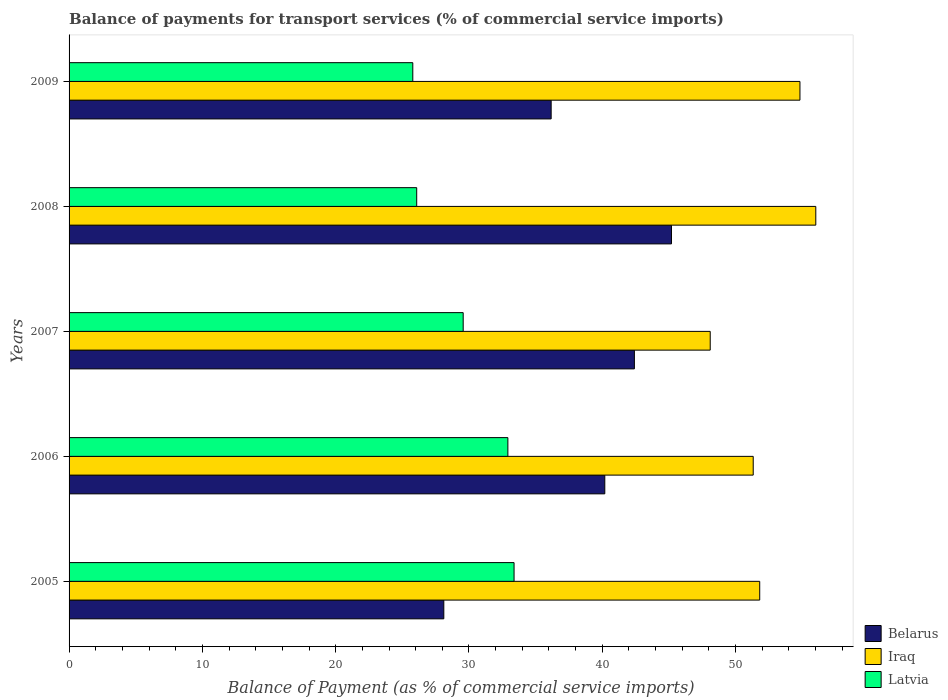In how many cases, is the number of bars for a given year not equal to the number of legend labels?
Offer a terse response. 0. What is the balance of payments for transport services in Iraq in 2006?
Ensure brevity in your answer.  51.32. Across all years, what is the maximum balance of payments for transport services in Iraq?
Your answer should be compact. 56.02. Across all years, what is the minimum balance of payments for transport services in Latvia?
Ensure brevity in your answer.  25.79. What is the total balance of payments for transport services in Iraq in the graph?
Your answer should be compact. 262.07. What is the difference between the balance of payments for transport services in Iraq in 2008 and that in 2009?
Offer a terse response. 1.19. What is the difference between the balance of payments for transport services in Latvia in 2008 and the balance of payments for transport services in Iraq in 2007?
Keep it short and to the point. -22.02. What is the average balance of payments for transport services in Belarus per year?
Offer a very short reply. 38.41. In the year 2007, what is the difference between the balance of payments for transport services in Latvia and balance of payments for transport services in Iraq?
Your response must be concise. -18.53. What is the ratio of the balance of payments for transport services in Iraq in 2006 to that in 2007?
Your response must be concise. 1.07. Is the balance of payments for transport services in Latvia in 2006 less than that in 2009?
Ensure brevity in your answer.  No. What is the difference between the highest and the second highest balance of payments for transport services in Belarus?
Provide a short and direct response. 2.78. What is the difference between the highest and the lowest balance of payments for transport services in Latvia?
Ensure brevity in your answer.  7.6. In how many years, is the balance of payments for transport services in Belarus greater than the average balance of payments for transport services in Belarus taken over all years?
Give a very brief answer. 3. What does the 1st bar from the top in 2006 represents?
Your response must be concise. Latvia. What does the 3rd bar from the bottom in 2008 represents?
Give a very brief answer. Latvia. Is it the case that in every year, the sum of the balance of payments for transport services in Latvia and balance of payments for transport services in Iraq is greater than the balance of payments for transport services in Belarus?
Offer a terse response. Yes. Are all the bars in the graph horizontal?
Your response must be concise. Yes. What is the difference between two consecutive major ticks on the X-axis?
Give a very brief answer. 10. Does the graph contain grids?
Your answer should be very brief. No. Where does the legend appear in the graph?
Make the answer very short. Bottom right. What is the title of the graph?
Provide a short and direct response. Balance of payments for transport services (% of commercial service imports). Does "Tanzania" appear as one of the legend labels in the graph?
Give a very brief answer. No. What is the label or title of the X-axis?
Offer a terse response. Balance of Payment (as % of commercial service imports). What is the label or title of the Y-axis?
Keep it short and to the point. Years. What is the Balance of Payment (as % of commercial service imports) of Belarus in 2005?
Your response must be concise. 28.11. What is the Balance of Payment (as % of commercial service imports) in Iraq in 2005?
Give a very brief answer. 51.81. What is the Balance of Payment (as % of commercial service imports) in Latvia in 2005?
Offer a terse response. 33.38. What is the Balance of Payment (as % of commercial service imports) of Belarus in 2006?
Give a very brief answer. 40.19. What is the Balance of Payment (as % of commercial service imports) in Iraq in 2006?
Offer a terse response. 51.32. What is the Balance of Payment (as % of commercial service imports) in Latvia in 2006?
Offer a terse response. 32.92. What is the Balance of Payment (as % of commercial service imports) in Belarus in 2007?
Provide a succinct answer. 42.41. What is the Balance of Payment (as % of commercial service imports) of Iraq in 2007?
Your answer should be compact. 48.1. What is the Balance of Payment (as % of commercial service imports) in Latvia in 2007?
Give a very brief answer. 29.56. What is the Balance of Payment (as % of commercial service imports) in Belarus in 2008?
Keep it short and to the point. 45.19. What is the Balance of Payment (as % of commercial service imports) in Iraq in 2008?
Offer a terse response. 56.02. What is the Balance of Payment (as % of commercial service imports) of Latvia in 2008?
Make the answer very short. 26.08. What is the Balance of Payment (as % of commercial service imports) in Belarus in 2009?
Your answer should be very brief. 36.16. What is the Balance of Payment (as % of commercial service imports) of Iraq in 2009?
Offer a terse response. 54.83. What is the Balance of Payment (as % of commercial service imports) of Latvia in 2009?
Offer a terse response. 25.79. Across all years, what is the maximum Balance of Payment (as % of commercial service imports) of Belarus?
Your answer should be very brief. 45.19. Across all years, what is the maximum Balance of Payment (as % of commercial service imports) in Iraq?
Your answer should be compact. 56.02. Across all years, what is the maximum Balance of Payment (as % of commercial service imports) in Latvia?
Ensure brevity in your answer.  33.38. Across all years, what is the minimum Balance of Payment (as % of commercial service imports) in Belarus?
Make the answer very short. 28.11. Across all years, what is the minimum Balance of Payment (as % of commercial service imports) in Iraq?
Give a very brief answer. 48.1. Across all years, what is the minimum Balance of Payment (as % of commercial service imports) of Latvia?
Offer a very short reply. 25.79. What is the total Balance of Payment (as % of commercial service imports) of Belarus in the graph?
Give a very brief answer. 192.06. What is the total Balance of Payment (as % of commercial service imports) in Iraq in the graph?
Your answer should be very brief. 262.07. What is the total Balance of Payment (as % of commercial service imports) in Latvia in the graph?
Your response must be concise. 147.73. What is the difference between the Balance of Payment (as % of commercial service imports) of Belarus in 2005 and that in 2006?
Provide a succinct answer. -12.08. What is the difference between the Balance of Payment (as % of commercial service imports) of Iraq in 2005 and that in 2006?
Offer a very short reply. 0.49. What is the difference between the Balance of Payment (as % of commercial service imports) of Latvia in 2005 and that in 2006?
Offer a very short reply. 0.46. What is the difference between the Balance of Payment (as % of commercial service imports) in Belarus in 2005 and that in 2007?
Offer a very short reply. -14.3. What is the difference between the Balance of Payment (as % of commercial service imports) of Iraq in 2005 and that in 2007?
Offer a very short reply. 3.71. What is the difference between the Balance of Payment (as % of commercial service imports) in Latvia in 2005 and that in 2007?
Offer a very short reply. 3.82. What is the difference between the Balance of Payment (as % of commercial service imports) in Belarus in 2005 and that in 2008?
Provide a succinct answer. -17.08. What is the difference between the Balance of Payment (as % of commercial service imports) of Iraq in 2005 and that in 2008?
Provide a short and direct response. -4.21. What is the difference between the Balance of Payment (as % of commercial service imports) of Latvia in 2005 and that in 2008?
Provide a short and direct response. 7.3. What is the difference between the Balance of Payment (as % of commercial service imports) of Belarus in 2005 and that in 2009?
Provide a short and direct response. -8.05. What is the difference between the Balance of Payment (as % of commercial service imports) of Iraq in 2005 and that in 2009?
Your answer should be very brief. -3.02. What is the difference between the Balance of Payment (as % of commercial service imports) of Latvia in 2005 and that in 2009?
Make the answer very short. 7.6. What is the difference between the Balance of Payment (as % of commercial service imports) of Belarus in 2006 and that in 2007?
Provide a short and direct response. -2.22. What is the difference between the Balance of Payment (as % of commercial service imports) in Iraq in 2006 and that in 2007?
Offer a very short reply. 3.22. What is the difference between the Balance of Payment (as % of commercial service imports) of Latvia in 2006 and that in 2007?
Your answer should be compact. 3.35. What is the difference between the Balance of Payment (as % of commercial service imports) in Belarus in 2006 and that in 2008?
Provide a short and direct response. -5. What is the difference between the Balance of Payment (as % of commercial service imports) in Iraq in 2006 and that in 2008?
Ensure brevity in your answer.  -4.69. What is the difference between the Balance of Payment (as % of commercial service imports) of Latvia in 2006 and that in 2008?
Your answer should be compact. 6.84. What is the difference between the Balance of Payment (as % of commercial service imports) of Belarus in 2006 and that in 2009?
Ensure brevity in your answer.  4.02. What is the difference between the Balance of Payment (as % of commercial service imports) in Iraq in 2006 and that in 2009?
Your answer should be very brief. -3.51. What is the difference between the Balance of Payment (as % of commercial service imports) of Latvia in 2006 and that in 2009?
Provide a short and direct response. 7.13. What is the difference between the Balance of Payment (as % of commercial service imports) in Belarus in 2007 and that in 2008?
Your answer should be very brief. -2.78. What is the difference between the Balance of Payment (as % of commercial service imports) of Iraq in 2007 and that in 2008?
Your answer should be very brief. -7.92. What is the difference between the Balance of Payment (as % of commercial service imports) in Latvia in 2007 and that in 2008?
Your answer should be compact. 3.49. What is the difference between the Balance of Payment (as % of commercial service imports) in Belarus in 2007 and that in 2009?
Offer a very short reply. 6.24. What is the difference between the Balance of Payment (as % of commercial service imports) in Iraq in 2007 and that in 2009?
Offer a terse response. -6.73. What is the difference between the Balance of Payment (as % of commercial service imports) of Latvia in 2007 and that in 2009?
Your answer should be compact. 3.78. What is the difference between the Balance of Payment (as % of commercial service imports) in Belarus in 2008 and that in 2009?
Keep it short and to the point. 9.03. What is the difference between the Balance of Payment (as % of commercial service imports) in Iraq in 2008 and that in 2009?
Provide a succinct answer. 1.19. What is the difference between the Balance of Payment (as % of commercial service imports) of Latvia in 2008 and that in 2009?
Make the answer very short. 0.29. What is the difference between the Balance of Payment (as % of commercial service imports) in Belarus in 2005 and the Balance of Payment (as % of commercial service imports) in Iraq in 2006?
Provide a succinct answer. -23.21. What is the difference between the Balance of Payment (as % of commercial service imports) in Belarus in 2005 and the Balance of Payment (as % of commercial service imports) in Latvia in 2006?
Offer a terse response. -4.81. What is the difference between the Balance of Payment (as % of commercial service imports) in Iraq in 2005 and the Balance of Payment (as % of commercial service imports) in Latvia in 2006?
Your answer should be very brief. 18.89. What is the difference between the Balance of Payment (as % of commercial service imports) of Belarus in 2005 and the Balance of Payment (as % of commercial service imports) of Iraq in 2007?
Your answer should be very brief. -19.99. What is the difference between the Balance of Payment (as % of commercial service imports) in Belarus in 2005 and the Balance of Payment (as % of commercial service imports) in Latvia in 2007?
Ensure brevity in your answer.  -1.45. What is the difference between the Balance of Payment (as % of commercial service imports) of Iraq in 2005 and the Balance of Payment (as % of commercial service imports) of Latvia in 2007?
Provide a succinct answer. 22.24. What is the difference between the Balance of Payment (as % of commercial service imports) of Belarus in 2005 and the Balance of Payment (as % of commercial service imports) of Iraq in 2008?
Your response must be concise. -27.9. What is the difference between the Balance of Payment (as % of commercial service imports) in Belarus in 2005 and the Balance of Payment (as % of commercial service imports) in Latvia in 2008?
Offer a very short reply. 2.03. What is the difference between the Balance of Payment (as % of commercial service imports) in Iraq in 2005 and the Balance of Payment (as % of commercial service imports) in Latvia in 2008?
Give a very brief answer. 25.73. What is the difference between the Balance of Payment (as % of commercial service imports) in Belarus in 2005 and the Balance of Payment (as % of commercial service imports) in Iraq in 2009?
Your answer should be compact. -26.72. What is the difference between the Balance of Payment (as % of commercial service imports) in Belarus in 2005 and the Balance of Payment (as % of commercial service imports) in Latvia in 2009?
Give a very brief answer. 2.33. What is the difference between the Balance of Payment (as % of commercial service imports) of Iraq in 2005 and the Balance of Payment (as % of commercial service imports) of Latvia in 2009?
Keep it short and to the point. 26.02. What is the difference between the Balance of Payment (as % of commercial service imports) of Belarus in 2006 and the Balance of Payment (as % of commercial service imports) of Iraq in 2007?
Ensure brevity in your answer.  -7.91. What is the difference between the Balance of Payment (as % of commercial service imports) of Belarus in 2006 and the Balance of Payment (as % of commercial service imports) of Latvia in 2007?
Offer a terse response. 10.62. What is the difference between the Balance of Payment (as % of commercial service imports) in Iraq in 2006 and the Balance of Payment (as % of commercial service imports) in Latvia in 2007?
Ensure brevity in your answer.  21.76. What is the difference between the Balance of Payment (as % of commercial service imports) in Belarus in 2006 and the Balance of Payment (as % of commercial service imports) in Iraq in 2008?
Offer a terse response. -15.83. What is the difference between the Balance of Payment (as % of commercial service imports) in Belarus in 2006 and the Balance of Payment (as % of commercial service imports) in Latvia in 2008?
Give a very brief answer. 14.11. What is the difference between the Balance of Payment (as % of commercial service imports) of Iraq in 2006 and the Balance of Payment (as % of commercial service imports) of Latvia in 2008?
Your answer should be very brief. 25.24. What is the difference between the Balance of Payment (as % of commercial service imports) of Belarus in 2006 and the Balance of Payment (as % of commercial service imports) of Iraq in 2009?
Provide a succinct answer. -14.64. What is the difference between the Balance of Payment (as % of commercial service imports) of Belarus in 2006 and the Balance of Payment (as % of commercial service imports) of Latvia in 2009?
Offer a terse response. 14.4. What is the difference between the Balance of Payment (as % of commercial service imports) in Iraq in 2006 and the Balance of Payment (as % of commercial service imports) in Latvia in 2009?
Ensure brevity in your answer.  25.54. What is the difference between the Balance of Payment (as % of commercial service imports) in Belarus in 2007 and the Balance of Payment (as % of commercial service imports) in Iraq in 2008?
Provide a succinct answer. -13.61. What is the difference between the Balance of Payment (as % of commercial service imports) of Belarus in 2007 and the Balance of Payment (as % of commercial service imports) of Latvia in 2008?
Offer a terse response. 16.33. What is the difference between the Balance of Payment (as % of commercial service imports) in Iraq in 2007 and the Balance of Payment (as % of commercial service imports) in Latvia in 2008?
Make the answer very short. 22.02. What is the difference between the Balance of Payment (as % of commercial service imports) of Belarus in 2007 and the Balance of Payment (as % of commercial service imports) of Iraq in 2009?
Your response must be concise. -12.42. What is the difference between the Balance of Payment (as % of commercial service imports) of Belarus in 2007 and the Balance of Payment (as % of commercial service imports) of Latvia in 2009?
Keep it short and to the point. 16.62. What is the difference between the Balance of Payment (as % of commercial service imports) in Iraq in 2007 and the Balance of Payment (as % of commercial service imports) in Latvia in 2009?
Offer a terse response. 22.31. What is the difference between the Balance of Payment (as % of commercial service imports) of Belarus in 2008 and the Balance of Payment (as % of commercial service imports) of Iraq in 2009?
Offer a very short reply. -9.64. What is the difference between the Balance of Payment (as % of commercial service imports) in Belarus in 2008 and the Balance of Payment (as % of commercial service imports) in Latvia in 2009?
Your response must be concise. 19.41. What is the difference between the Balance of Payment (as % of commercial service imports) in Iraq in 2008 and the Balance of Payment (as % of commercial service imports) in Latvia in 2009?
Your answer should be very brief. 30.23. What is the average Balance of Payment (as % of commercial service imports) of Belarus per year?
Your answer should be very brief. 38.41. What is the average Balance of Payment (as % of commercial service imports) of Iraq per year?
Give a very brief answer. 52.41. What is the average Balance of Payment (as % of commercial service imports) in Latvia per year?
Your response must be concise. 29.55. In the year 2005, what is the difference between the Balance of Payment (as % of commercial service imports) of Belarus and Balance of Payment (as % of commercial service imports) of Iraq?
Provide a short and direct response. -23.7. In the year 2005, what is the difference between the Balance of Payment (as % of commercial service imports) in Belarus and Balance of Payment (as % of commercial service imports) in Latvia?
Ensure brevity in your answer.  -5.27. In the year 2005, what is the difference between the Balance of Payment (as % of commercial service imports) of Iraq and Balance of Payment (as % of commercial service imports) of Latvia?
Offer a terse response. 18.43. In the year 2006, what is the difference between the Balance of Payment (as % of commercial service imports) in Belarus and Balance of Payment (as % of commercial service imports) in Iraq?
Ensure brevity in your answer.  -11.13. In the year 2006, what is the difference between the Balance of Payment (as % of commercial service imports) in Belarus and Balance of Payment (as % of commercial service imports) in Latvia?
Provide a succinct answer. 7.27. In the year 2006, what is the difference between the Balance of Payment (as % of commercial service imports) in Iraq and Balance of Payment (as % of commercial service imports) in Latvia?
Keep it short and to the point. 18.4. In the year 2007, what is the difference between the Balance of Payment (as % of commercial service imports) of Belarus and Balance of Payment (as % of commercial service imports) of Iraq?
Provide a short and direct response. -5.69. In the year 2007, what is the difference between the Balance of Payment (as % of commercial service imports) in Belarus and Balance of Payment (as % of commercial service imports) in Latvia?
Your answer should be compact. 12.84. In the year 2007, what is the difference between the Balance of Payment (as % of commercial service imports) in Iraq and Balance of Payment (as % of commercial service imports) in Latvia?
Offer a very short reply. 18.53. In the year 2008, what is the difference between the Balance of Payment (as % of commercial service imports) of Belarus and Balance of Payment (as % of commercial service imports) of Iraq?
Offer a very short reply. -10.83. In the year 2008, what is the difference between the Balance of Payment (as % of commercial service imports) of Belarus and Balance of Payment (as % of commercial service imports) of Latvia?
Your answer should be compact. 19.11. In the year 2008, what is the difference between the Balance of Payment (as % of commercial service imports) in Iraq and Balance of Payment (as % of commercial service imports) in Latvia?
Your answer should be compact. 29.94. In the year 2009, what is the difference between the Balance of Payment (as % of commercial service imports) in Belarus and Balance of Payment (as % of commercial service imports) in Iraq?
Your answer should be compact. -18.66. In the year 2009, what is the difference between the Balance of Payment (as % of commercial service imports) of Belarus and Balance of Payment (as % of commercial service imports) of Latvia?
Ensure brevity in your answer.  10.38. In the year 2009, what is the difference between the Balance of Payment (as % of commercial service imports) in Iraq and Balance of Payment (as % of commercial service imports) in Latvia?
Offer a terse response. 29.04. What is the ratio of the Balance of Payment (as % of commercial service imports) in Belarus in 2005 to that in 2006?
Your answer should be very brief. 0.7. What is the ratio of the Balance of Payment (as % of commercial service imports) of Iraq in 2005 to that in 2006?
Your response must be concise. 1.01. What is the ratio of the Balance of Payment (as % of commercial service imports) in Latvia in 2005 to that in 2006?
Provide a short and direct response. 1.01. What is the ratio of the Balance of Payment (as % of commercial service imports) in Belarus in 2005 to that in 2007?
Your answer should be compact. 0.66. What is the ratio of the Balance of Payment (as % of commercial service imports) of Iraq in 2005 to that in 2007?
Give a very brief answer. 1.08. What is the ratio of the Balance of Payment (as % of commercial service imports) in Latvia in 2005 to that in 2007?
Offer a very short reply. 1.13. What is the ratio of the Balance of Payment (as % of commercial service imports) of Belarus in 2005 to that in 2008?
Offer a terse response. 0.62. What is the ratio of the Balance of Payment (as % of commercial service imports) of Iraq in 2005 to that in 2008?
Provide a short and direct response. 0.92. What is the ratio of the Balance of Payment (as % of commercial service imports) of Latvia in 2005 to that in 2008?
Your answer should be very brief. 1.28. What is the ratio of the Balance of Payment (as % of commercial service imports) of Belarus in 2005 to that in 2009?
Make the answer very short. 0.78. What is the ratio of the Balance of Payment (as % of commercial service imports) of Iraq in 2005 to that in 2009?
Give a very brief answer. 0.94. What is the ratio of the Balance of Payment (as % of commercial service imports) in Latvia in 2005 to that in 2009?
Ensure brevity in your answer.  1.29. What is the ratio of the Balance of Payment (as % of commercial service imports) in Belarus in 2006 to that in 2007?
Provide a succinct answer. 0.95. What is the ratio of the Balance of Payment (as % of commercial service imports) of Iraq in 2006 to that in 2007?
Make the answer very short. 1.07. What is the ratio of the Balance of Payment (as % of commercial service imports) in Latvia in 2006 to that in 2007?
Provide a short and direct response. 1.11. What is the ratio of the Balance of Payment (as % of commercial service imports) of Belarus in 2006 to that in 2008?
Make the answer very short. 0.89. What is the ratio of the Balance of Payment (as % of commercial service imports) of Iraq in 2006 to that in 2008?
Provide a succinct answer. 0.92. What is the ratio of the Balance of Payment (as % of commercial service imports) in Latvia in 2006 to that in 2008?
Keep it short and to the point. 1.26. What is the ratio of the Balance of Payment (as % of commercial service imports) in Belarus in 2006 to that in 2009?
Provide a succinct answer. 1.11. What is the ratio of the Balance of Payment (as % of commercial service imports) in Iraq in 2006 to that in 2009?
Keep it short and to the point. 0.94. What is the ratio of the Balance of Payment (as % of commercial service imports) in Latvia in 2006 to that in 2009?
Offer a very short reply. 1.28. What is the ratio of the Balance of Payment (as % of commercial service imports) of Belarus in 2007 to that in 2008?
Offer a very short reply. 0.94. What is the ratio of the Balance of Payment (as % of commercial service imports) in Iraq in 2007 to that in 2008?
Make the answer very short. 0.86. What is the ratio of the Balance of Payment (as % of commercial service imports) of Latvia in 2007 to that in 2008?
Your answer should be very brief. 1.13. What is the ratio of the Balance of Payment (as % of commercial service imports) of Belarus in 2007 to that in 2009?
Give a very brief answer. 1.17. What is the ratio of the Balance of Payment (as % of commercial service imports) in Iraq in 2007 to that in 2009?
Your answer should be very brief. 0.88. What is the ratio of the Balance of Payment (as % of commercial service imports) of Latvia in 2007 to that in 2009?
Make the answer very short. 1.15. What is the ratio of the Balance of Payment (as % of commercial service imports) of Belarus in 2008 to that in 2009?
Give a very brief answer. 1.25. What is the ratio of the Balance of Payment (as % of commercial service imports) in Iraq in 2008 to that in 2009?
Offer a very short reply. 1.02. What is the ratio of the Balance of Payment (as % of commercial service imports) of Latvia in 2008 to that in 2009?
Provide a short and direct response. 1.01. What is the difference between the highest and the second highest Balance of Payment (as % of commercial service imports) in Belarus?
Your response must be concise. 2.78. What is the difference between the highest and the second highest Balance of Payment (as % of commercial service imports) in Iraq?
Provide a short and direct response. 1.19. What is the difference between the highest and the second highest Balance of Payment (as % of commercial service imports) of Latvia?
Keep it short and to the point. 0.46. What is the difference between the highest and the lowest Balance of Payment (as % of commercial service imports) of Belarus?
Make the answer very short. 17.08. What is the difference between the highest and the lowest Balance of Payment (as % of commercial service imports) of Iraq?
Make the answer very short. 7.92. What is the difference between the highest and the lowest Balance of Payment (as % of commercial service imports) of Latvia?
Offer a very short reply. 7.6. 